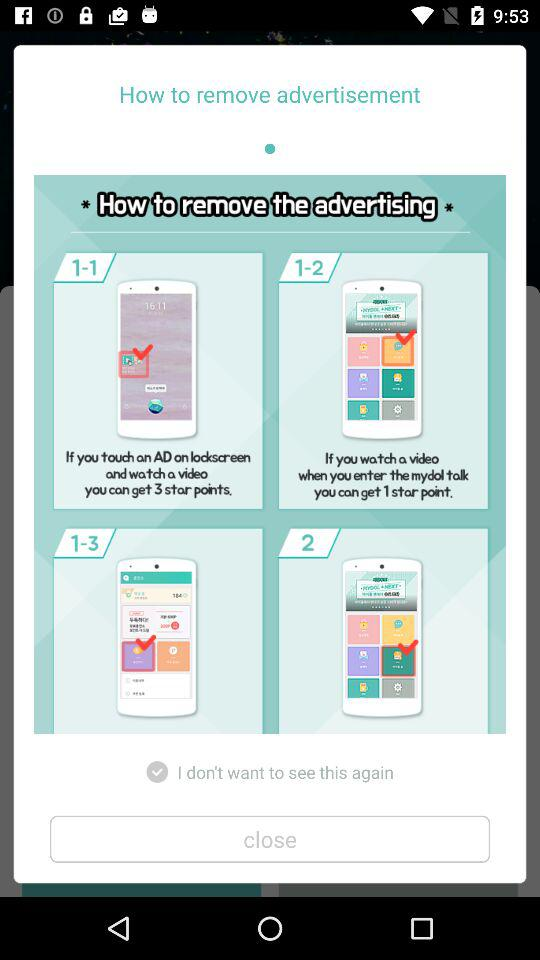What is the description for step 2?
When the provided information is insufficient, respond with <no answer>. <no answer> 